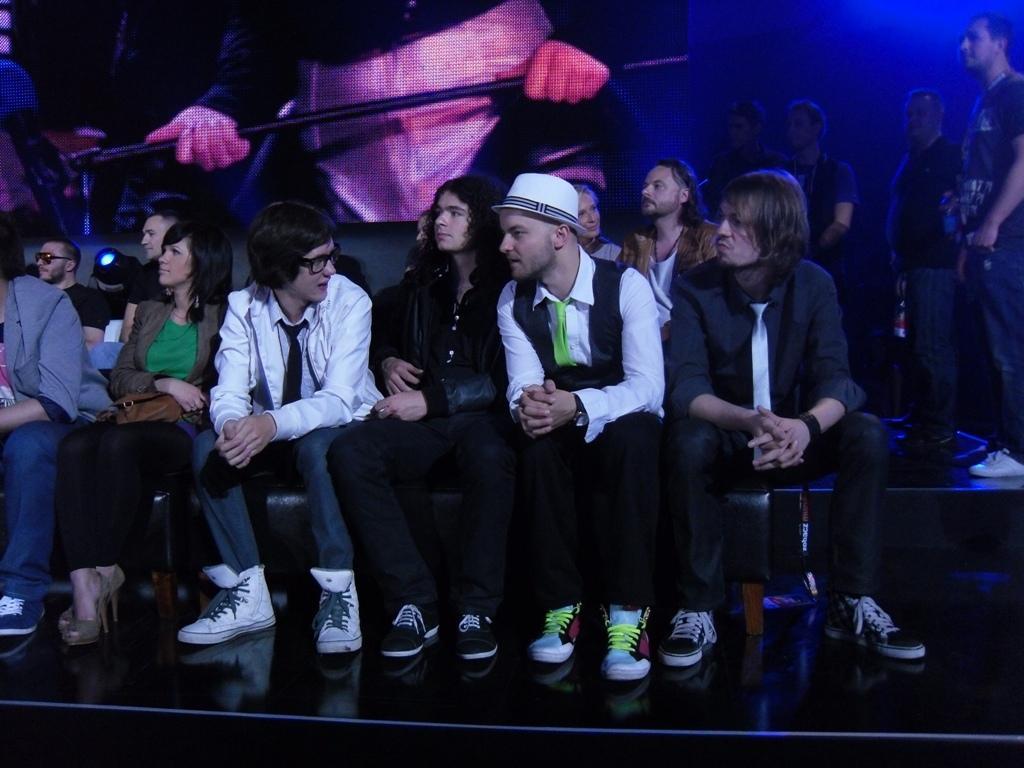Can you describe this image briefly? In this image there are a few people sitting and standing, behind them there is a poster of a person holding a rod. 